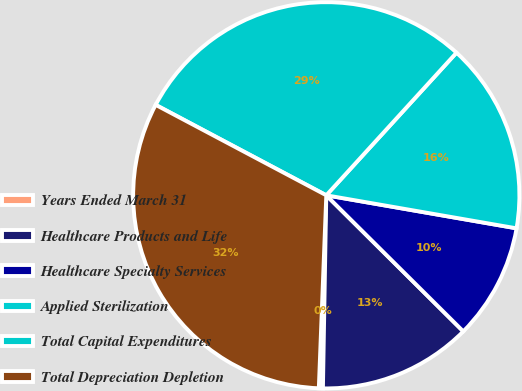Convert chart to OTSL. <chart><loc_0><loc_0><loc_500><loc_500><pie_chart><fcel>Years Ended March 31<fcel>Healthcare Products and Life<fcel>Healthcare Specialty Services<fcel>Applied Sterilization<fcel>Total Capital Expenditures<fcel>Total Depreciation Depletion<nl><fcel>0.34%<fcel>12.83%<fcel>9.71%<fcel>15.96%<fcel>29.02%<fcel>32.14%<nl></chart> 